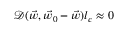Convert formula to latex. <formula><loc_0><loc_0><loc_500><loc_500>\mathcal { D } ( \vec { w } , \vec { w } _ { 0 } - \vec { w } ) l _ { c } \approx 0</formula> 